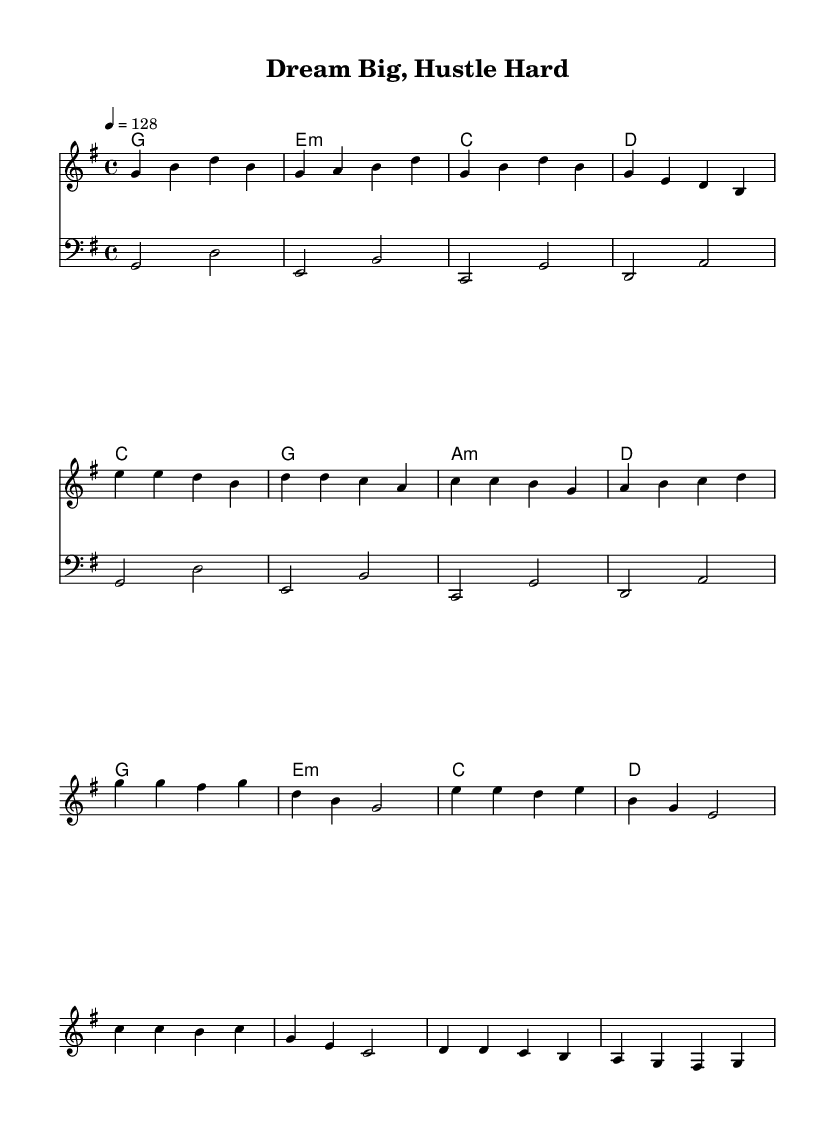What is the key signature of this music? The key signature is G major, which has one sharp (F#). You can determine this from the 'g' in the key command and identify the sharp indicated in the key signature section.
Answer: G major What is the time signature? The time signature is 4/4, as indicated at the beginning of the music. This shows that there are four beats in each measure and the quarter note gets one beat.
Answer: 4/4 What is the tempo marking? The tempo marking is 128 beats per minute. This is specified by "4 = 128" in the tempo directive.
Answer: 128 How many measures are in the verse section? There are four measures in the verse section, which can be counted directly from the melody line indicated for the verse.
Answer: 4 What chords are used in the pre-chorus? The chords used in the pre-chorus are C, G, A minor, and D. This can be verified in the chord section accompanying the melody for that specific part of the song.
Answer: C, G, A minor, D What is the highest note in the melody? The highest note in the melody is E. You can find this by analyzing the pitch of each note in the melody line and identifying that E is the highest note reached.
Answer: E What is the overall structure of the song? The overall structure consists of a verse, pre-chorus, and chorus, as indicated in the arrangement of the sections in the sheet music. This can be deduced from the labeling of the musical sections.
Answer: Verse, pre-chorus, chorus 